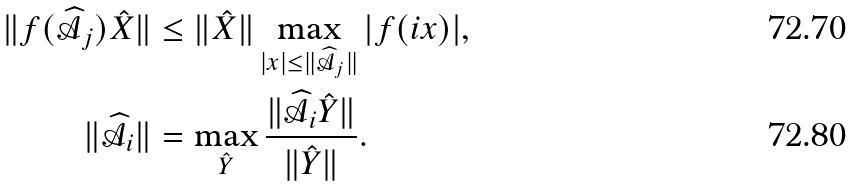<formula> <loc_0><loc_0><loc_500><loc_500>\| f ( \widehat { \mathcal { A } } _ { j } ) \hat { X } \| & \leq \| \hat { X } \| \max _ { | x | \leq \| \widehat { \mathcal { A } } _ { j } \| } | f ( i x ) | , \\ \| \widehat { \mathcal { A } } _ { i } \| & = \max _ { \hat { Y } } \frac { \| \widehat { \mathcal { A } } _ { i } \hat { Y } \| } { \| \hat { Y } \| } .</formula> 